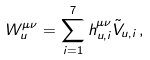<formula> <loc_0><loc_0><loc_500><loc_500>W _ { u } ^ { \mu \nu } = \sum _ { i = 1 } ^ { 7 } h _ { u , i } ^ { \mu \nu } \tilde { V } _ { u , i } \, ,</formula> 